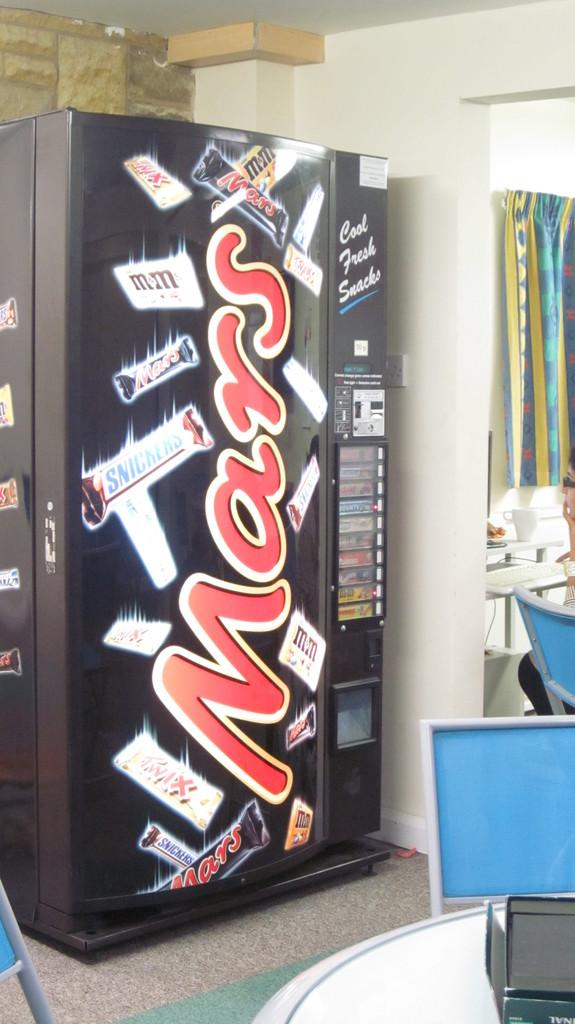<image>
Write a terse but informative summary of the picture. A candy vending machine that says MARS on it is in a room with a table. 